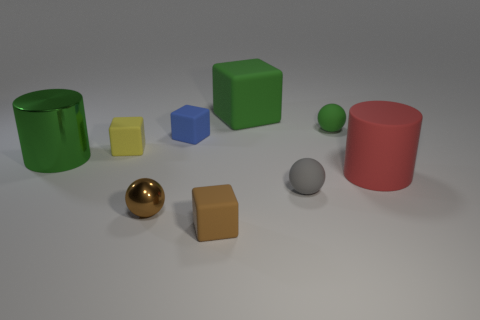What is the size of the rubber object that is the same color as the metallic sphere?
Offer a terse response. Small. There is a green object that is the same size as the yellow matte block; what material is it?
Provide a short and direct response. Rubber. Is there a brown sphere that has the same material as the blue thing?
Give a very brief answer. No. Is there a large green metal thing that is behind the cylinder that is left of the small cube on the left side of the tiny brown metal thing?
Provide a short and direct response. No. The yellow matte thing that is the same size as the green rubber ball is what shape?
Provide a succinct answer. Cube. There is a metallic object that is right of the small yellow rubber object; does it have the same size as the green object on the left side of the yellow thing?
Offer a very short reply. No. How many large yellow metal balls are there?
Offer a terse response. 0. There is a green shiny thing that is behind the tiny sphere on the left side of the big rubber object that is behind the small yellow matte object; what is its size?
Ensure brevity in your answer.  Large. Do the large metallic thing and the big cube have the same color?
Provide a succinct answer. Yes. What number of small green matte spheres are left of the green cube?
Offer a terse response. 0. 